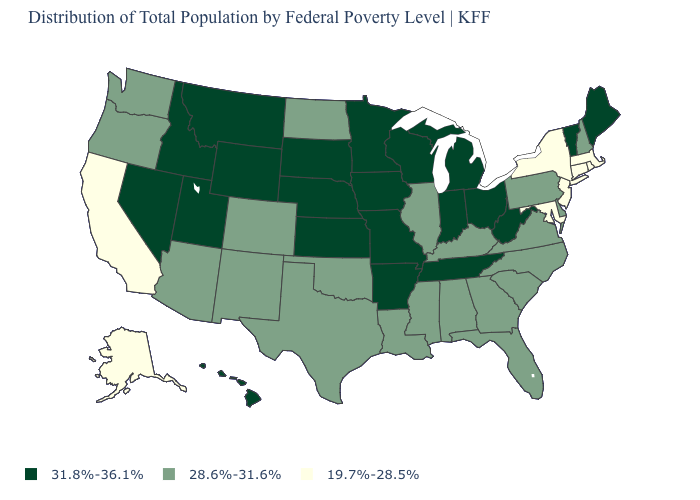Name the states that have a value in the range 28.6%-31.6%?
Answer briefly. Alabama, Arizona, Colorado, Delaware, Florida, Georgia, Illinois, Kentucky, Louisiana, Mississippi, New Hampshire, New Mexico, North Carolina, North Dakota, Oklahoma, Oregon, Pennsylvania, South Carolina, Texas, Virginia, Washington. What is the value of Maine?
Short answer required. 31.8%-36.1%. How many symbols are there in the legend?
Answer briefly. 3. What is the value of Iowa?
Quick response, please. 31.8%-36.1%. Does New Jersey have the same value as Maryland?
Be succinct. Yes. Name the states that have a value in the range 19.7%-28.5%?
Write a very short answer. Alaska, California, Connecticut, Maryland, Massachusetts, New Jersey, New York, Rhode Island. Is the legend a continuous bar?
Give a very brief answer. No. Is the legend a continuous bar?
Be succinct. No. What is the lowest value in the USA?
Write a very short answer. 19.7%-28.5%. What is the highest value in states that border Oklahoma?
Give a very brief answer. 31.8%-36.1%. Name the states that have a value in the range 31.8%-36.1%?
Keep it brief. Arkansas, Hawaii, Idaho, Indiana, Iowa, Kansas, Maine, Michigan, Minnesota, Missouri, Montana, Nebraska, Nevada, Ohio, South Dakota, Tennessee, Utah, Vermont, West Virginia, Wisconsin, Wyoming. What is the highest value in the USA?
Short answer required. 31.8%-36.1%. Name the states that have a value in the range 19.7%-28.5%?
Keep it brief. Alaska, California, Connecticut, Maryland, Massachusetts, New Jersey, New York, Rhode Island. Name the states that have a value in the range 31.8%-36.1%?
Keep it brief. Arkansas, Hawaii, Idaho, Indiana, Iowa, Kansas, Maine, Michigan, Minnesota, Missouri, Montana, Nebraska, Nevada, Ohio, South Dakota, Tennessee, Utah, Vermont, West Virginia, Wisconsin, Wyoming. Name the states that have a value in the range 31.8%-36.1%?
Concise answer only. Arkansas, Hawaii, Idaho, Indiana, Iowa, Kansas, Maine, Michigan, Minnesota, Missouri, Montana, Nebraska, Nevada, Ohio, South Dakota, Tennessee, Utah, Vermont, West Virginia, Wisconsin, Wyoming. 